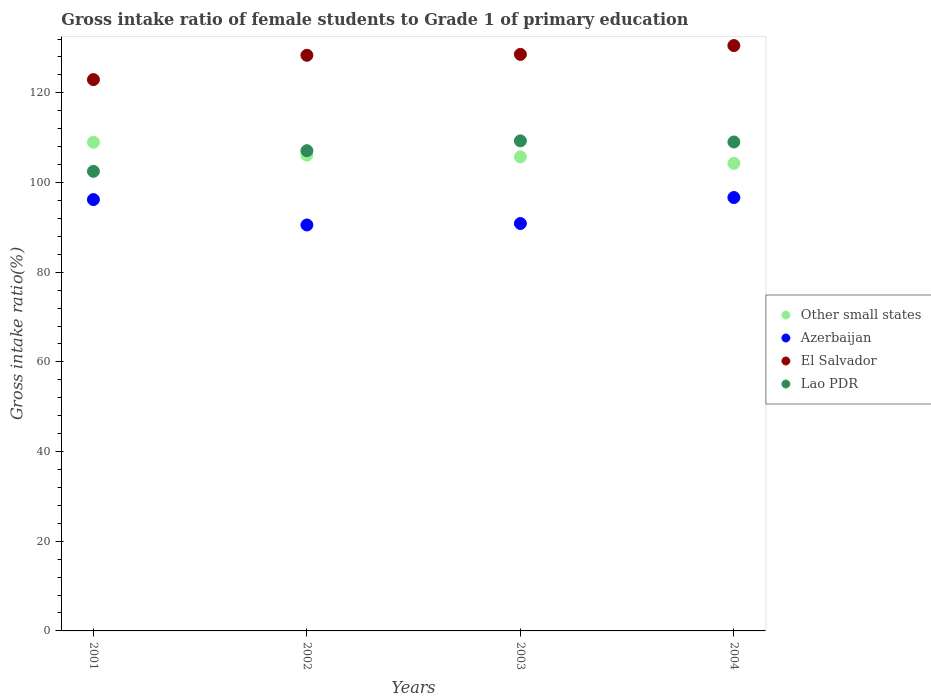How many different coloured dotlines are there?
Your answer should be compact. 4. What is the gross intake ratio in Azerbaijan in 2001?
Provide a short and direct response. 96.19. Across all years, what is the maximum gross intake ratio in Lao PDR?
Ensure brevity in your answer.  109.29. Across all years, what is the minimum gross intake ratio in Lao PDR?
Ensure brevity in your answer.  102.5. What is the total gross intake ratio in Lao PDR in the graph?
Ensure brevity in your answer.  427.92. What is the difference between the gross intake ratio in El Salvador in 2003 and that in 2004?
Provide a short and direct response. -1.97. What is the difference between the gross intake ratio in El Salvador in 2004 and the gross intake ratio in Other small states in 2002?
Your response must be concise. 24.44. What is the average gross intake ratio in Lao PDR per year?
Your answer should be compact. 106.98. In the year 2003, what is the difference between the gross intake ratio in Other small states and gross intake ratio in Azerbaijan?
Your answer should be compact. 14.87. In how many years, is the gross intake ratio in Lao PDR greater than 100 %?
Your answer should be very brief. 4. What is the ratio of the gross intake ratio in Azerbaijan in 2001 to that in 2002?
Ensure brevity in your answer.  1.06. Is the gross intake ratio in Lao PDR in 2002 less than that in 2004?
Your answer should be compact. Yes. Is the difference between the gross intake ratio in Other small states in 2002 and 2003 greater than the difference between the gross intake ratio in Azerbaijan in 2002 and 2003?
Keep it short and to the point. Yes. What is the difference between the highest and the second highest gross intake ratio in Lao PDR?
Provide a succinct answer. 0.25. What is the difference between the highest and the lowest gross intake ratio in Lao PDR?
Give a very brief answer. 6.79. In how many years, is the gross intake ratio in Azerbaijan greater than the average gross intake ratio in Azerbaijan taken over all years?
Give a very brief answer. 2. Is the sum of the gross intake ratio in El Salvador in 2001 and 2002 greater than the maximum gross intake ratio in Other small states across all years?
Your answer should be compact. Yes. Is it the case that in every year, the sum of the gross intake ratio in Lao PDR and gross intake ratio in Other small states  is greater than the sum of gross intake ratio in Azerbaijan and gross intake ratio in El Salvador?
Make the answer very short. Yes. Is it the case that in every year, the sum of the gross intake ratio in Other small states and gross intake ratio in Lao PDR  is greater than the gross intake ratio in El Salvador?
Give a very brief answer. Yes. Is the gross intake ratio in El Salvador strictly greater than the gross intake ratio in Lao PDR over the years?
Your answer should be compact. Yes. Are the values on the major ticks of Y-axis written in scientific E-notation?
Keep it short and to the point. No. Does the graph contain grids?
Provide a succinct answer. No. What is the title of the graph?
Your response must be concise. Gross intake ratio of female students to Grade 1 of primary education. Does "Georgia" appear as one of the legend labels in the graph?
Keep it short and to the point. No. What is the label or title of the Y-axis?
Provide a succinct answer. Gross intake ratio(%). What is the Gross intake ratio(%) in Other small states in 2001?
Keep it short and to the point. 108.98. What is the Gross intake ratio(%) in Azerbaijan in 2001?
Your response must be concise. 96.19. What is the Gross intake ratio(%) of El Salvador in 2001?
Give a very brief answer. 122.95. What is the Gross intake ratio(%) of Lao PDR in 2001?
Give a very brief answer. 102.5. What is the Gross intake ratio(%) in Other small states in 2002?
Your answer should be very brief. 106.1. What is the Gross intake ratio(%) in Azerbaijan in 2002?
Keep it short and to the point. 90.53. What is the Gross intake ratio(%) in El Salvador in 2002?
Make the answer very short. 128.37. What is the Gross intake ratio(%) in Lao PDR in 2002?
Offer a terse response. 107.1. What is the Gross intake ratio(%) of Other small states in 2003?
Your response must be concise. 105.73. What is the Gross intake ratio(%) of Azerbaijan in 2003?
Give a very brief answer. 90.86. What is the Gross intake ratio(%) of El Salvador in 2003?
Offer a terse response. 128.57. What is the Gross intake ratio(%) of Lao PDR in 2003?
Provide a short and direct response. 109.29. What is the Gross intake ratio(%) of Other small states in 2004?
Your answer should be very brief. 104.27. What is the Gross intake ratio(%) in Azerbaijan in 2004?
Offer a terse response. 96.66. What is the Gross intake ratio(%) in El Salvador in 2004?
Your response must be concise. 130.54. What is the Gross intake ratio(%) in Lao PDR in 2004?
Your response must be concise. 109.04. Across all years, what is the maximum Gross intake ratio(%) in Other small states?
Your response must be concise. 108.98. Across all years, what is the maximum Gross intake ratio(%) in Azerbaijan?
Your answer should be very brief. 96.66. Across all years, what is the maximum Gross intake ratio(%) in El Salvador?
Your response must be concise. 130.54. Across all years, what is the maximum Gross intake ratio(%) of Lao PDR?
Your answer should be compact. 109.29. Across all years, what is the minimum Gross intake ratio(%) in Other small states?
Provide a succinct answer. 104.27. Across all years, what is the minimum Gross intake ratio(%) in Azerbaijan?
Your answer should be compact. 90.53. Across all years, what is the minimum Gross intake ratio(%) of El Salvador?
Provide a succinct answer. 122.95. Across all years, what is the minimum Gross intake ratio(%) in Lao PDR?
Ensure brevity in your answer.  102.5. What is the total Gross intake ratio(%) in Other small states in the graph?
Offer a terse response. 425.08. What is the total Gross intake ratio(%) in Azerbaijan in the graph?
Your answer should be very brief. 374.24. What is the total Gross intake ratio(%) of El Salvador in the graph?
Offer a terse response. 510.44. What is the total Gross intake ratio(%) in Lao PDR in the graph?
Ensure brevity in your answer.  427.92. What is the difference between the Gross intake ratio(%) of Other small states in 2001 and that in 2002?
Your answer should be compact. 2.88. What is the difference between the Gross intake ratio(%) of Azerbaijan in 2001 and that in 2002?
Your response must be concise. 5.66. What is the difference between the Gross intake ratio(%) in El Salvador in 2001 and that in 2002?
Make the answer very short. -5.42. What is the difference between the Gross intake ratio(%) in Lao PDR in 2001 and that in 2002?
Keep it short and to the point. -4.6. What is the difference between the Gross intake ratio(%) in Other small states in 2001 and that in 2003?
Give a very brief answer. 3.25. What is the difference between the Gross intake ratio(%) of Azerbaijan in 2001 and that in 2003?
Make the answer very short. 5.33. What is the difference between the Gross intake ratio(%) of El Salvador in 2001 and that in 2003?
Offer a terse response. -5.62. What is the difference between the Gross intake ratio(%) of Lao PDR in 2001 and that in 2003?
Ensure brevity in your answer.  -6.79. What is the difference between the Gross intake ratio(%) in Other small states in 2001 and that in 2004?
Offer a very short reply. 4.71. What is the difference between the Gross intake ratio(%) of Azerbaijan in 2001 and that in 2004?
Give a very brief answer. -0.46. What is the difference between the Gross intake ratio(%) of El Salvador in 2001 and that in 2004?
Your response must be concise. -7.59. What is the difference between the Gross intake ratio(%) of Lao PDR in 2001 and that in 2004?
Keep it short and to the point. -6.54. What is the difference between the Gross intake ratio(%) of Other small states in 2002 and that in 2003?
Offer a very short reply. 0.38. What is the difference between the Gross intake ratio(%) in Azerbaijan in 2002 and that in 2003?
Offer a terse response. -0.33. What is the difference between the Gross intake ratio(%) of El Salvador in 2002 and that in 2003?
Your response must be concise. -0.2. What is the difference between the Gross intake ratio(%) of Lao PDR in 2002 and that in 2003?
Offer a terse response. -2.19. What is the difference between the Gross intake ratio(%) of Other small states in 2002 and that in 2004?
Your answer should be compact. 1.83. What is the difference between the Gross intake ratio(%) in Azerbaijan in 2002 and that in 2004?
Give a very brief answer. -6.12. What is the difference between the Gross intake ratio(%) of El Salvador in 2002 and that in 2004?
Your response must be concise. -2.17. What is the difference between the Gross intake ratio(%) in Lao PDR in 2002 and that in 2004?
Keep it short and to the point. -1.94. What is the difference between the Gross intake ratio(%) of Other small states in 2003 and that in 2004?
Make the answer very short. 1.46. What is the difference between the Gross intake ratio(%) of Azerbaijan in 2003 and that in 2004?
Make the answer very short. -5.8. What is the difference between the Gross intake ratio(%) in El Salvador in 2003 and that in 2004?
Ensure brevity in your answer.  -1.97. What is the difference between the Gross intake ratio(%) of Lao PDR in 2003 and that in 2004?
Keep it short and to the point. 0.25. What is the difference between the Gross intake ratio(%) of Other small states in 2001 and the Gross intake ratio(%) of Azerbaijan in 2002?
Keep it short and to the point. 18.45. What is the difference between the Gross intake ratio(%) of Other small states in 2001 and the Gross intake ratio(%) of El Salvador in 2002?
Make the answer very short. -19.39. What is the difference between the Gross intake ratio(%) of Other small states in 2001 and the Gross intake ratio(%) of Lao PDR in 2002?
Your answer should be very brief. 1.88. What is the difference between the Gross intake ratio(%) of Azerbaijan in 2001 and the Gross intake ratio(%) of El Salvador in 2002?
Make the answer very short. -32.18. What is the difference between the Gross intake ratio(%) of Azerbaijan in 2001 and the Gross intake ratio(%) of Lao PDR in 2002?
Keep it short and to the point. -10.9. What is the difference between the Gross intake ratio(%) in El Salvador in 2001 and the Gross intake ratio(%) in Lao PDR in 2002?
Your answer should be compact. 15.85. What is the difference between the Gross intake ratio(%) of Other small states in 2001 and the Gross intake ratio(%) of Azerbaijan in 2003?
Offer a very short reply. 18.12. What is the difference between the Gross intake ratio(%) of Other small states in 2001 and the Gross intake ratio(%) of El Salvador in 2003?
Provide a short and direct response. -19.59. What is the difference between the Gross intake ratio(%) of Other small states in 2001 and the Gross intake ratio(%) of Lao PDR in 2003?
Give a very brief answer. -0.31. What is the difference between the Gross intake ratio(%) of Azerbaijan in 2001 and the Gross intake ratio(%) of El Salvador in 2003?
Offer a very short reply. -32.38. What is the difference between the Gross intake ratio(%) of Azerbaijan in 2001 and the Gross intake ratio(%) of Lao PDR in 2003?
Your answer should be very brief. -13.09. What is the difference between the Gross intake ratio(%) in El Salvador in 2001 and the Gross intake ratio(%) in Lao PDR in 2003?
Your response must be concise. 13.66. What is the difference between the Gross intake ratio(%) of Other small states in 2001 and the Gross intake ratio(%) of Azerbaijan in 2004?
Provide a short and direct response. 12.33. What is the difference between the Gross intake ratio(%) of Other small states in 2001 and the Gross intake ratio(%) of El Salvador in 2004?
Provide a succinct answer. -21.56. What is the difference between the Gross intake ratio(%) of Other small states in 2001 and the Gross intake ratio(%) of Lao PDR in 2004?
Ensure brevity in your answer.  -0.06. What is the difference between the Gross intake ratio(%) in Azerbaijan in 2001 and the Gross intake ratio(%) in El Salvador in 2004?
Provide a succinct answer. -34.35. What is the difference between the Gross intake ratio(%) in Azerbaijan in 2001 and the Gross intake ratio(%) in Lao PDR in 2004?
Your answer should be very brief. -12.85. What is the difference between the Gross intake ratio(%) of El Salvador in 2001 and the Gross intake ratio(%) of Lao PDR in 2004?
Provide a succinct answer. 13.91. What is the difference between the Gross intake ratio(%) of Other small states in 2002 and the Gross intake ratio(%) of Azerbaijan in 2003?
Give a very brief answer. 15.24. What is the difference between the Gross intake ratio(%) in Other small states in 2002 and the Gross intake ratio(%) in El Salvador in 2003?
Make the answer very short. -22.47. What is the difference between the Gross intake ratio(%) in Other small states in 2002 and the Gross intake ratio(%) in Lao PDR in 2003?
Give a very brief answer. -3.18. What is the difference between the Gross intake ratio(%) in Azerbaijan in 2002 and the Gross intake ratio(%) in El Salvador in 2003?
Your answer should be very brief. -38.04. What is the difference between the Gross intake ratio(%) of Azerbaijan in 2002 and the Gross intake ratio(%) of Lao PDR in 2003?
Provide a short and direct response. -18.75. What is the difference between the Gross intake ratio(%) of El Salvador in 2002 and the Gross intake ratio(%) of Lao PDR in 2003?
Offer a very short reply. 19.09. What is the difference between the Gross intake ratio(%) in Other small states in 2002 and the Gross intake ratio(%) in Azerbaijan in 2004?
Keep it short and to the point. 9.45. What is the difference between the Gross intake ratio(%) of Other small states in 2002 and the Gross intake ratio(%) of El Salvador in 2004?
Ensure brevity in your answer.  -24.44. What is the difference between the Gross intake ratio(%) in Other small states in 2002 and the Gross intake ratio(%) in Lao PDR in 2004?
Provide a succinct answer. -2.94. What is the difference between the Gross intake ratio(%) of Azerbaijan in 2002 and the Gross intake ratio(%) of El Salvador in 2004?
Make the answer very short. -40.01. What is the difference between the Gross intake ratio(%) of Azerbaijan in 2002 and the Gross intake ratio(%) of Lao PDR in 2004?
Offer a terse response. -18.5. What is the difference between the Gross intake ratio(%) in El Salvador in 2002 and the Gross intake ratio(%) in Lao PDR in 2004?
Make the answer very short. 19.34. What is the difference between the Gross intake ratio(%) in Other small states in 2003 and the Gross intake ratio(%) in Azerbaijan in 2004?
Keep it short and to the point. 9.07. What is the difference between the Gross intake ratio(%) of Other small states in 2003 and the Gross intake ratio(%) of El Salvador in 2004?
Keep it short and to the point. -24.82. What is the difference between the Gross intake ratio(%) of Other small states in 2003 and the Gross intake ratio(%) of Lao PDR in 2004?
Your response must be concise. -3.31. What is the difference between the Gross intake ratio(%) in Azerbaijan in 2003 and the Gross intake ratio(%) in El Salvador in 2004?
Offer a terse response. -39.69. What is the difference between the Gross intake ratio(%) in Azerbaijan in 2003 and the Gross intake ratio(%) in Lao PDR in 2004?
Give a very brief answer. -18.18. What is the difference between the Gross intake ratio(%) of El Salvador in 2003 and the Gross intake ratio(%) of Lao PDR in 2004?
Give a very brief answer. 19.54. What is the average Gross intake ratio(%) in Other small states per year?
Provide a succinct answer. 106.27. What is the average Gross intake ratio(%) of Azerbaijan per year?
Your answer should be compact. 93.56. What is the average Gross intake ratio(%) of El Salvador per year?
Provide a short and direct response. 127.61. What is the average Gross intake ratio(%) of Lao PDR per year?
Provide a succinct answer. 106.98. In the year 2001, what is the difference between the Gross intake ratio(%) of Other small states and Gross intake ratio(%) of Azerbaijan?
Offer a terse response. 12.79. In the year 2001, what is the difference between the Gross intake ratio(%) in Other small states and Gross intake ratio(%) in El Salvador?
Your answer should be very brief. -13.97. In the year 2001, what is the difference between the Gross intake ratio(%) of Other small states and Gross intake ratio(%) of Lao PDR?
Offer a terse response. 6.48. In the year 2001, what is the difference between the Gross intake ratio(%) of Azerbaijan and Gross intake ratio(%) of El Salvador?
Offer a very short reply. -26.76. In the year 2001, what is the difference between the Gross intake ratio(%) of Azerbaijan and Gross intake ratio(%) of Lao PDR?
Offer a terse response. -6.3. In the year 2001, what is the difference between the Gross intake ratio(%) of El Salvador and Gross intake ratio(%) of Lao PDR?
Your response must be concise. 20.45. In the year 2002, what is the difference between the Gross intake ratio(%) in Other small states and Gross intake ratio(%) in Azerbaijan?
Your response must be concise. 15.57. In the year 2002, what is the difference between the Gross intake ratio(%) of Other small states and Gross intake ratio(%) of El Salvador?
Offer a very short reply. -22.27. In the year 2002, what is the difference between the Gross intake ratio(%) of Other small states and Gross intake ratio(%) of Lao PDR?
Offer a terse response. -0.99. In the year 2002, what is the difference between the Gross intake ratio(%) of Azerbaijan and Gross intake ratio(%) of El Salvador?
Your response must be concise. -37.84. In the year 2002, what is the difference between the Gross intake ratio(%) of Azerbaijan and Gross intake ratio(%) of Lao PDR?
Make the answer very short. -16.56. In the year 2002, what is the difference between the Gross intake ratio(%) in El Salvador and Gross intake ratio(%) in Lao PDR?
Provide a short and direct response. 21.28. In the year 2003, what is the difference between the Gross intake ratio(%) in Other small states and Gross intake ratio(%) in Azerbaijan?
Your response must be concise. 14.87. In the year 2003, what is the difference between the Gross intake ratio(%) of Other small states and Gross intake ratio(%) of El Salvador?
Offer a terse response. -22.85. In the year 2003, what is the difference between the Gross intake ratio(%) of Other small states and Gross intake ratio(%) of Lao PDR?
Your answer should be very brief. -3.56. In the year 2003, what is the difference between the Gross intake ratio(%) of Azerbaijan and Gross intake ratio(%) of El Salvador?
Keep it short and to the point. -37.72. In the year 2003, what is the difference between the Gross intake ratio(%) of Azerbaijan and Gross intake ratio(%) of Lao PDR?
Your answer should be very brief. -18.43. In the year 2003, what is the difference between the Gross intake ratio(%) in El Salvador and Gross intake ratio(%) in Lao PDR?
Offer a terse response. 19.29. In the year 2004, what is the difference between the Gross intake ratio(%) of Other small states and Gross intake ratio(%) of Azerbaijan?
Give a very brief answer. 7.62. In the year 2004, what is the difference between the Gross intake ratio(%) of Other small states and Gross intake ratio(%) of El Salvador?
Your answer should be very brief. -26.27. In the year 2004, what is the difference between the Gross intake ratio(%) in Other small states and Gross intake ratio(%) in Lao PDR?
Keep it short and to the point. -4.77. In the year 2004, what is the difference between the Gross intake ratio(%) of Azerbaijan and Gross intake ratio(%) of El Salvador?
Keep it short and to the point. -33.89. In the year 2004, what is the difference between the Gross intake ratio(%) in Azerbaijan and Gross intake ratio(%) in Lao PDR?
Make the answer very short. -12.38. In the year 2004, what is the difference between the Gross intake ratio(%) in El Salvador and Gross intake ratio(%) in Lao PDR?
Offer a terse response. 21.51. What is the ratio of the Gross intake ratio(%) in Other small states in 2001 to that in 2002?
Your answer should be very brief. 1.03. What is the ratio of the Gross intake ratio(%) of Azerbaijan in 2001 to that in 2002?
Your response must be concise. 1.06. What is the ratio of the Gross intake ratio(%) in El Salvador in 2001 to that in 2002?
Keep it short and to the point. 0.96. What is the ratio of the Gross intake ratio(%) in Other small states in 2001 to that in 2003?
Your answer should be compact. 1.03. What is the ratio of the Gross intake ratio(%) of Azerbaijan in 2001 to that in 2003?
Offer a very short reply. 1.06. What is the ratio of the Gross intake ratio(%) in El Salvador in 2001 to that in 2003?
Your response must be concise. 0.96. What is the ratio of the Gross intake ratio(%) of Lao PDR in 2001 to that in 2003?
Offer a very short reply. 0.94. What is the ratio of the Gross intake ratio(%) of Other small states in 2001 to that in 2004?
Keep it short and to the point. 1.05. What is the ratio of the Gross intake ratio(%) in Azerbaijan in 2001 to that in 2004?
Your response must be concise. 1. What is the ratio of the Gross intake ratio(%) in El Salvador in 2001 to that in 2004?
Your answer should be very brief. 0.94. What is the ratio of the Gross intake ratio(%) of Other small states in 2002 to that in 2003?
Give a very brief answer. 1. What is the ratio of the Gross intake ratio(%) in El Salvador in 2002 to that in 2003?
Give a very brief answer. 1. What is the ratio of the Gross intake ratio(%) of Other small states in 2002 to that in 2004?
Give a very brief answer. 1.02. What is the ratio of the Gross intake ratio(%) in Azerbaijan in 2002 to that in 2004?
Your response must be concise. 0.94. What is the ratio of the Gross intake ratio(%) in El Salvador in 2002 to that in 2004?
Your answer should be compact. 0.98. What is the ratio of the Gross intake ratio(%) of Lao PDR in 2002 to that in 2004?
Offer a very short reply. 0.98. What is the ratio of the Gross intake ratio(%) of El Salvador in 2003 to that in 2004?
Provide a short and direct response. 0.98. What is the difference between the highest and the second highest Gross intake ratio(%) of Other small states?
Offer a terse response. 2.88. What is the difference between the highest and the second highest Gross intake ratio(%) of Azerbaijan?
Ensure brevity in your answer.  0.46. What is the difference between the highest and the second highest Gross intake ratio(%) of El Salvador?
Offer a terse response. 1.97. What is the difference between the highest and the second highest Gross intake ratio(%) in Lao PDR?
Make the answer very short. 0.25. What is the difference between the highest and the lowest Gross intake ratio(%) in Other small states?
Your answer should be very brief. 4.71. What is the difference between the highest and the lowest Gross intake ratio(%) in Azerbaijan?
Your answer should be compact. 6.12. What is the difference between the highest and the lowest Gross intake ratio(%) of El Salvador?
Provide a succinct answer. 7.59. What is the difference between the highest and the lowest Gross intake ratio(%) of Lao PDR?
Offer a terse response. 6.79. 